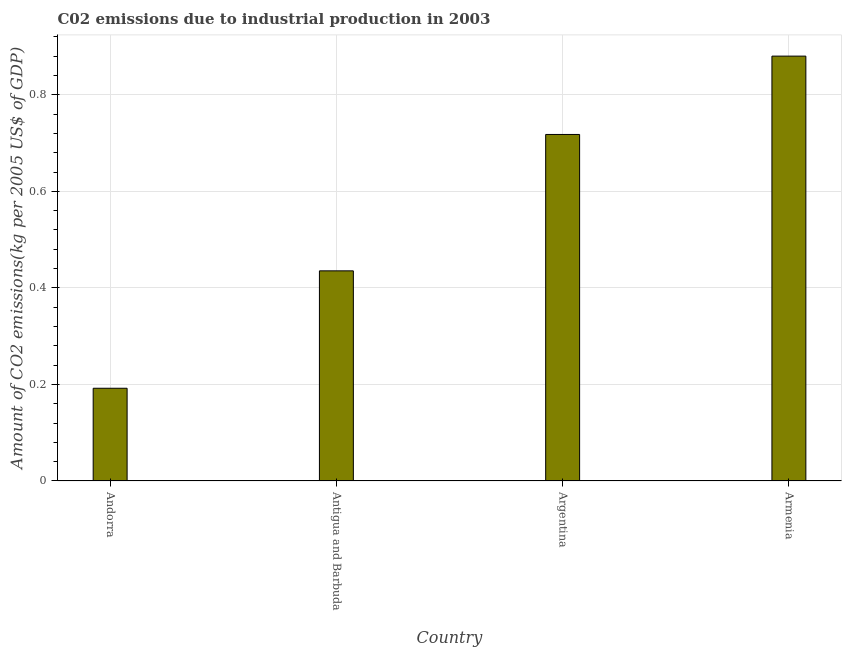Does the graph contain any zero values?
Provide a short and direct response. No. Does the graph contain grids?
Provide a short and direct response. Yes. What is the title of the graph?
Your answer should be very brief. C02 emissions due to industrial production in 2003. What is the label or title of the Y-axis?
Offer a terse response. Amount of CO2 emissions(kg per 2005 US$ of GDP). What is the amount of co2 emissions in Antigua and Barbuda?
Offer a terse response. 0.44. Across all countries, what is the maximum amount of co2 emissions?
Keep it short and to the point. 0.88. Across all countries, what is the minimum amount of co2 emissions?
Your answer should be compact. 0.19. In which country was the amount of co2 emissions maximum?
Provide a short and direct response. Armenia. In which country was the amount of co2 emissions minimum?
Your response must be concise. Andorra. What is the sum of the amount of co2 emissions?
Your answer should be compact. 2.23. What is the difference between the amount of co2 emissions in Antigua and Barbuda and Argentina?
Offer a terse response. -0.28. What is the average amount of co2 emissions per country?
Provide a succinct answer. 0.56. What is the median amount of co2 emissions?
Make the answer very short. 0.58. In how many countries, is the amount of co2 emissions greater than 0.48 kg per 2005 US$ of GDP?
Your answer should be very brief. 2. What is the ratio of the amount of co2 emissions in Andorra to that in Antigua and Barbuda?
Make the answer very short. 0.44. Is the amount of co2 emissions in Argentina less than that in Armenia?
Give a very brief answer. Yes. What is the difference between the highest and the second highest amount of co2 emissions?
Provide a succinct answer. 0.16. Is the sum of the amount of co2 emissions in Andorra and Argentina greater than the maximum amount of co2 emissions across all countries?
Ensure brevity in your answer.  Yes. What is the difference between the highest and the lowest amount of co2 emissions?
Your answer should be compact. 0.69. Are all the bars in the graph horizontal?
Keep it short and to the point. No. Are the values on the major ticks of Y-axis written in scientific E-notation?
Provide a succinct answer. No. What is the Amount of CO2 emissions(kg per 2005 US$ of GDP) in Andorra?
Offer a terse response. 0.19. What is the Amount of CO2 emissions(kg per 2005 US$ of GDP) in Antigua and Barbuda?
Keep it short and to the point. 0.44. What is the Amount of CO2 emissions(kg per 2005 US$ of GDP) in Argentina?
Ensure brevity in your answer.  0.72. What is the Amount of CO2 emissions(kg per 2005 US$ of GDP) of Armenia?
Provide a short and direct response. 0.88. What is the difference between the Amount of CO2 emissions(kg per 2005 US$ of GDP) in Andorra and Antigua and Barbuda?
Provide a short and direct response. -0.24. What is the difference between the Amount of CO2 emissions(kg per 2005 US$ of GDP) in Andorra and Argentina?
Provide a succinct answer. -0.53. What is the difference between the Amount of CO2 emissions(kg per 2005 US$ of GDP) in Andorra and Armenia?
Keep it short and to the point. -0.69. What is the difference between the Amount of CO2 emissions(kg per 2005 US$ of GDP) in Antigua and Barbuda and Argentina?
Offer a very short reply. -0.28. What is the difference between the Amount of CO2 emissions(kg per 2005 US$ of GDP) in Antigua and Barbuda and Armenia?
Offer a terse response. -0.44. What is the difference between the Amount of CO2 emissions(kg per 2005 US$ of GDP) in Argentina and Armenia?
Make the answer very short. -0.16. What is the ratio of the Amount of CO2 emissions(kg per 2005 US$ of GDP) in Andorra to that in Antigua and Barbuda?
Offer a very short reply. 0.44. What is the ratio of the Amount of CO2 emissions(kg per 2005 US$ of GDP) in Andorra to that in Argentina?
Make the answer very short. 0.27. What is the ratio of the Amount of CO2 emissions(kg per 2005 US$ of GDP) in Andorra to that in Armenia?
Your response must be concise. 0.22. What is the ratio of the Amount of CO2 emissions(kg per 2005 US$ of GDP) in Antigua and Barbuda to that in Argentina?
Provide a succinct answer. 0.61. What is the ratio of the Amount of CO2 emissions(kg per 2005 US$ of GDP) in Antigua and Barbuda to that in Armenia?
Offer a terse response. 0.49. What is the ratio of the Amount of CO2 emissions(kg per 2005 US$ of GDP) in Argentina to that in Armenia?
Keep it short and to the point. 0.82. 